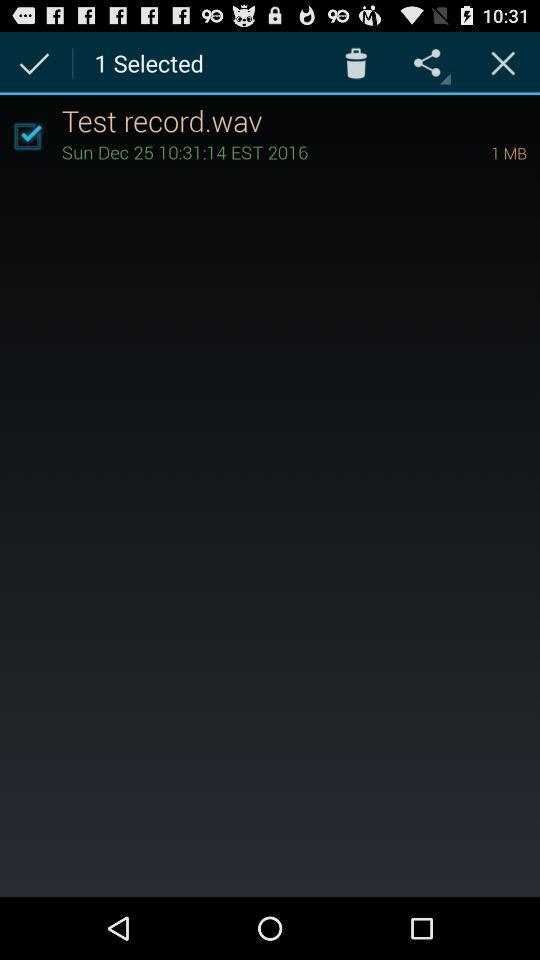What is the size of the "Test record.wav" file? The size of the "Test record.wav" file is 1 MB. 